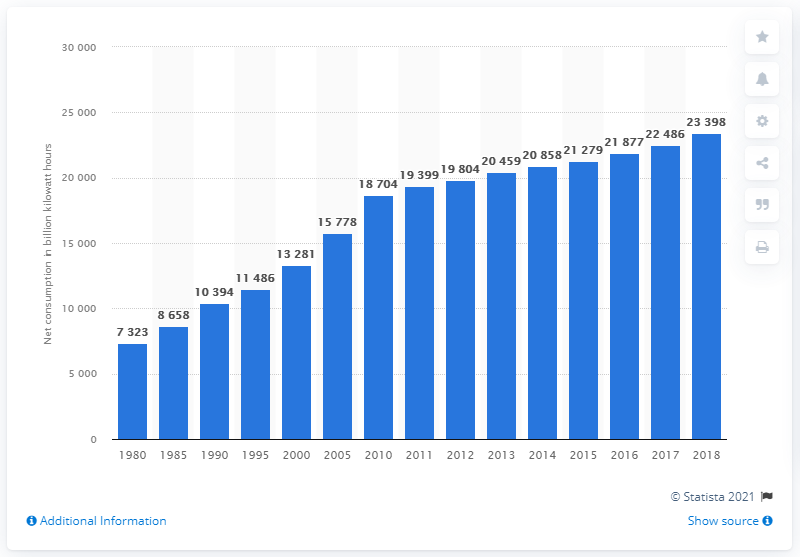When did global power use begin to see a more pronounced growth? Global power use began to see a more pronounced growth during the late 20th century, accelerating further from the early 1990s. As evident from the chart, there was a significant increase in net electricity consumption worldwide, jumping from approximately 11,486 billion kilowatt-hours in 1995 to about 18,704 billion kilowatt-hours in 2005. This trend reflects the impact of industrialization, population growth, and technological advancements. 